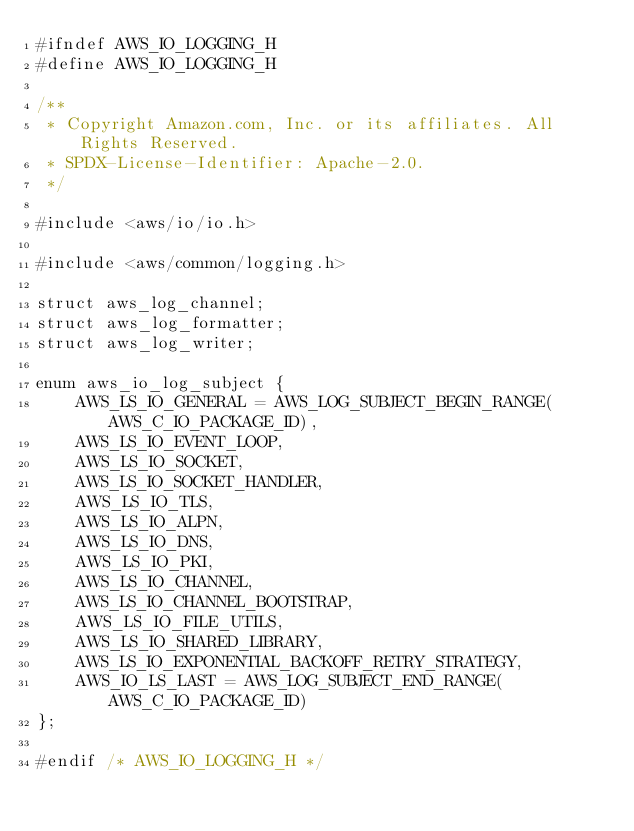<code> <loc_0><loc_0><loc_500><loc_500><_C_>#ifndef AWS_IO_LOGGING_H
#define AWS_IO_LOGGING_H

/**
 * Copyright Amazon.com, Inc. or its affiliates. All Rights Reserved.
 * SPDX-License-Identifier: Apache-2.0.
 */

#include <aws/io/io.h>

#include <aws/common/logging.h>

struct aws_log_channel;
struct aws_log_formatter;
struct aws_log_writer;

enum aws_io_log_subject {
    AWS_LS_IO_GENERAL = AWS_LOG_SUBJECT_BEGIN_RANGE(AWS_C_IO_PACKAGE_ID),
    AWS_LS_IO_EVENT_LOOP,
    AWS_LS_IO_SOCKET,
    AWS_LS_IO_SOCKET_HANDLER,
    AWS_LS_IO_TLS,
    AWS_LS_IO_ALPN,
    AWS_LS_IO_DNS,
    AWS_LS_IO_PKI,
    AWS_LS_IO_CHANNEL,
    AWS_LS_IO_CHANNEL_BOOTSTRAP,
    AWS_LS_IO_FILE_UTILS,
    AWS_LS_IO_SHARED_LIBRARY,
    AWS_LS_IO_EXPONENTIAL_BACKOFF_RETRY_STRATEGY,
    AWS_IO_LS_LAST = AWS_LOG_SUBJECT_END_RANGE(AWS_C_IO_PACKAGE_ID)
};

#endif /* AWS_IO_LOGGING_H */
</code> 